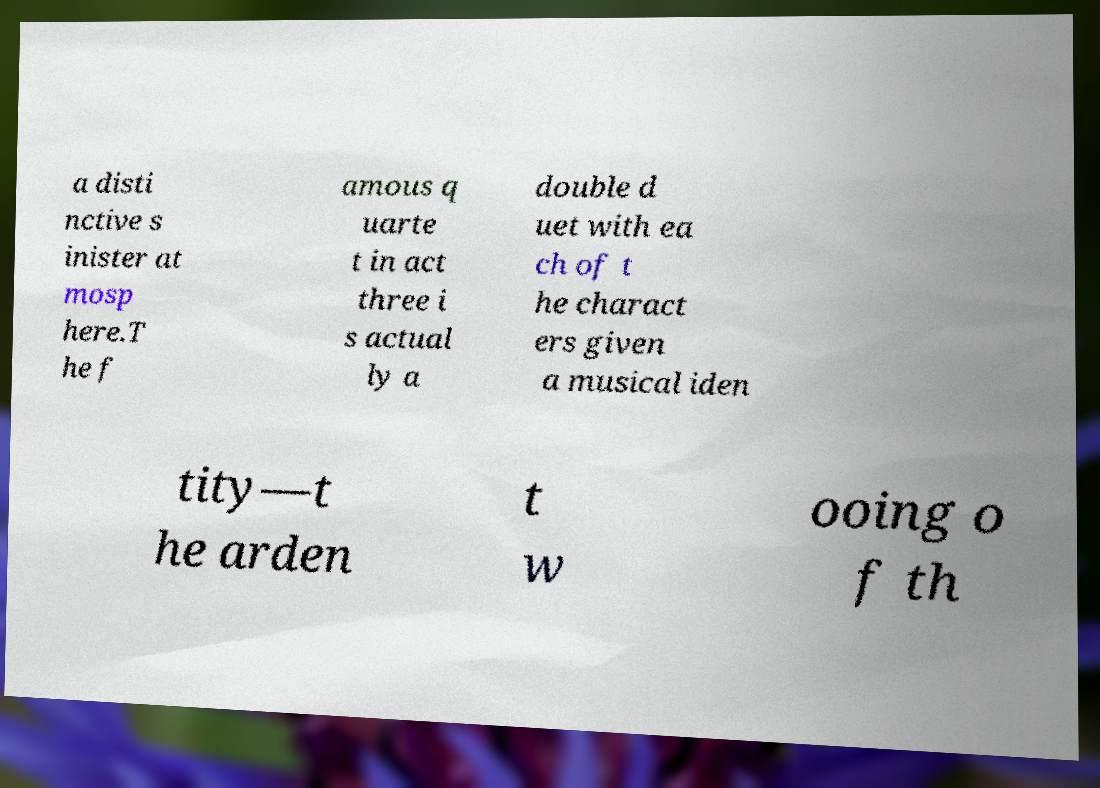Could you extract and type out the text from this image? a disti nctive s inister at mosp here.T he f amous q uarte t in act three i s actual ly a double d uet with ea ch of t he charact ers given a musical iden tity—t he arden t w ooing o f th 